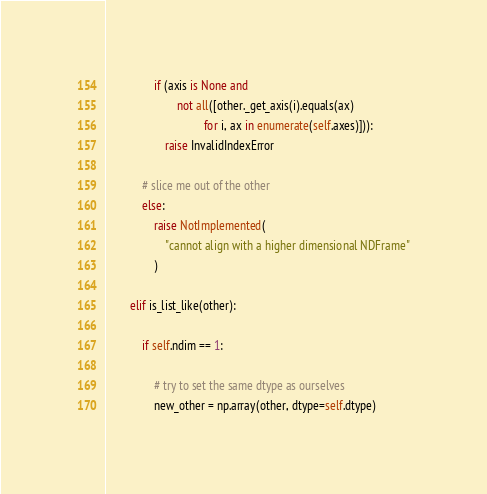Convert code to text. <code><loc_0><loc_0><loc_500><loc_500><_Python_>                if (axis is None and
                        not all([other._get_axis(i).equals(ax)
                                 for i, ax in enumerate(self.axes)])):
                    raise InvalidIndexError

            # slice me out of the other
            else:
                raise NotImplemented(
                    "cannot align with a higher dimensional NDFrame"
                )

        elif is_list_like(other):

            if self.ndim == 1:

                # try to set the same dtype as ourselves
                new_other = np.array(other, dtype=self.dtype)</code> 